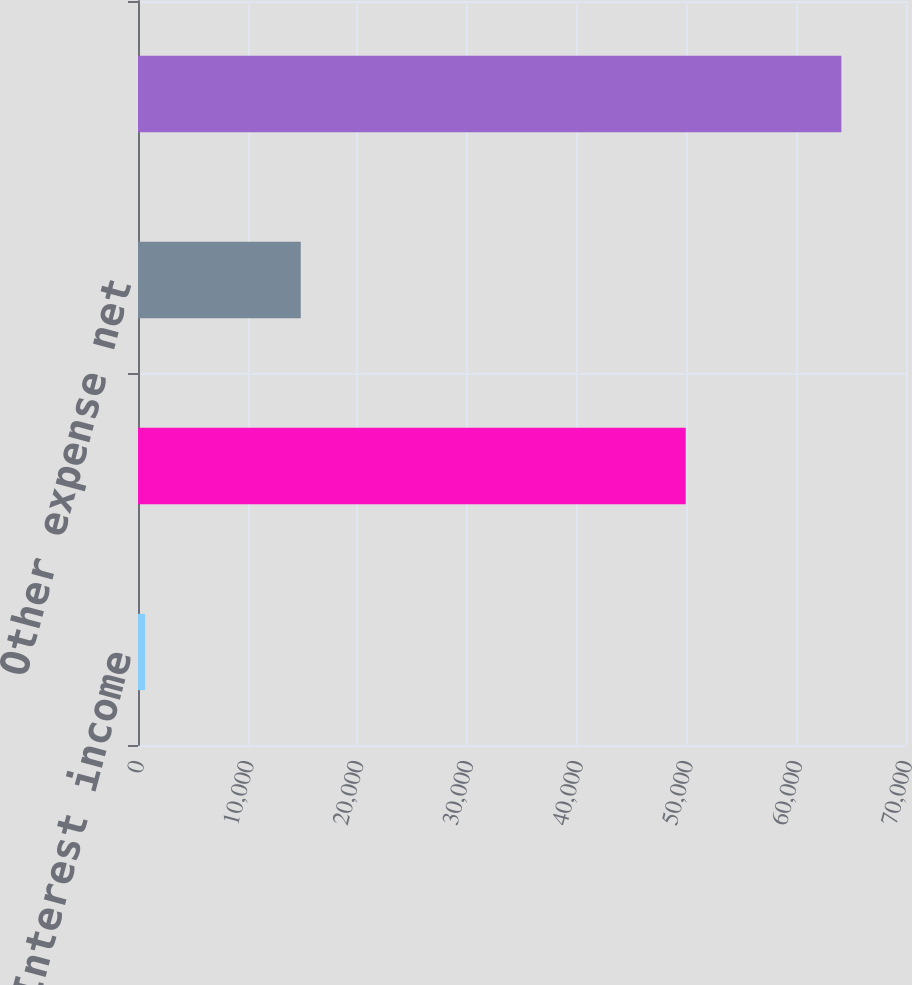Convert chart. <chart><loc_0><loc_0><loc_500><loc_500><bar_chart><fcel>Interest income<fcel>Interest expense<fcel>Other expense net<fcel>Total interest and other<nl><fcel>650<fcel>49924<fcel>14836<fcel>64110<nl></chart> 